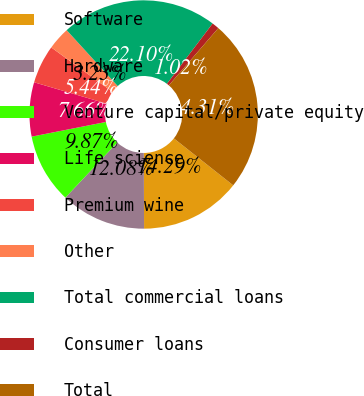Convert chart to OTSL. <chart><loc_0><loc_0><loc_500><loc_500><pie_chart><fcel>Software<fcel>Hardware<fcel>Venture capital/private equity<fcel>Life science<fcel>Premium wine<fcel>Other<fcel>Total commercial loans<fcel>Consumer loans<fcel>Total<nl><fcel>14.29%<fcel>12.08%<fcel>9.87%<fcel>7.66%<fcel>5.44%<fcel>3.23%<fcel>22.1%<fcel>1.02%<fcel>24.31%<nl></chart> 